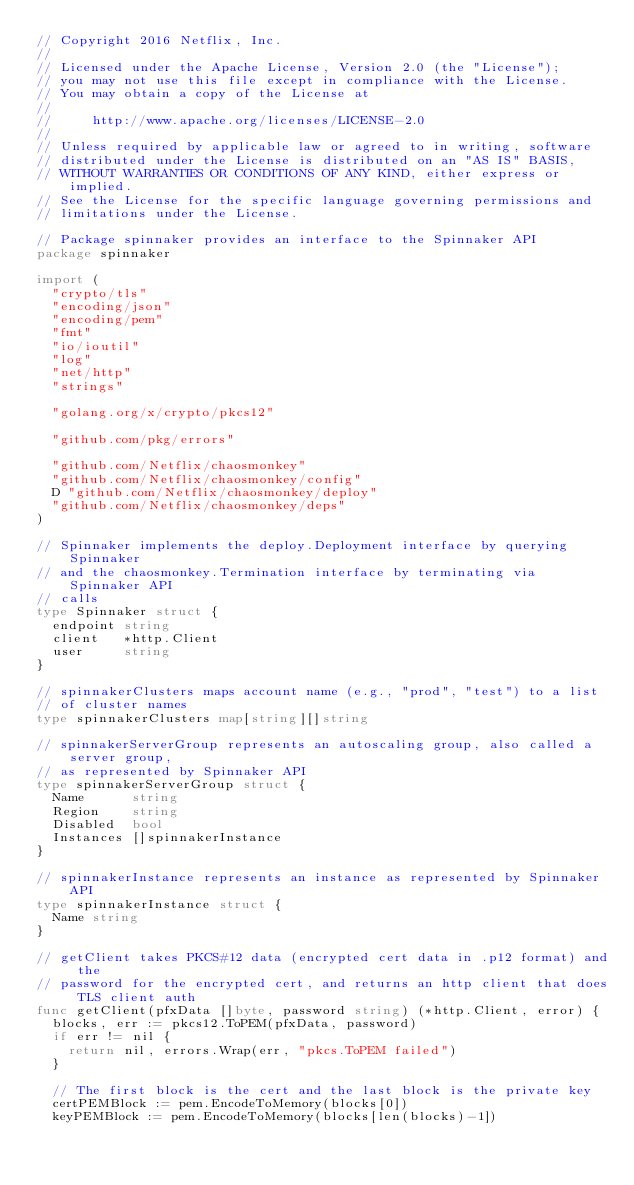Convert code to text. <code><loc_0><loc_0><loc_500><loc_500><_Go_>// Copyright 2016 Netflix, Inc.
//
// Licensed under the Apache License, Version 2.0 (the "License");
// you may not use this file except in compliance with the License.
// You may obtain a copy of the License at
//
//     http://www.apache.org/licenses/LICENSE-2.0
//
// Unless required by applicable law or agreed to in writing, software
// distributed under the License is distributed on an "AS IS" BASIS,
// WITHOUT WARRANTIES OR CONDITIONS OF ANY KIND, either express or implied.
// See the License for the specific language governing permissions and
// limitations under the License.

// Package spinnaker provides an interface to the Spinnaker API
package spinnaker

import (
	"crypto/tls"
	"encoding/json"
	"encoding/pem"
	"fmt"
	"io/ioutil"
	"log"
	"net/http"
	"strings"

	"golang.org/x/crypto/pkcs12"

	"github.com/pkg/errors"

	"github.com/Netflix/chaosmonkey"
	"github.com/Netflix/chaosmonkey/config"
	D "github.com/Netflix/chaosmonkey/deploy"
	"github.com/Netflix/chaosmonkey/deps"
)

// Spinnaker implements the deploy.Deployment interface by querying Spinnaker
// and the chaosmonkey.Termination interface by terminating via Spinnaker API
// calls
type Spinnaker struct {
	endpoint string
	client   *http.Client
	user     string
}

// spinnakerClusters maps account name (e.g., "prod", "test") to a list
// of cluster names
type spinnakerClusters map[string][]string

// spinnakerServerGroup represents an autoscaling group, also called a server group,
// as represented by Spinnaker API
type spinnakerServerGroup struct {
	Name      string
	Region    string
	Disabled  bool
	Instances []spinnakerInstance
}

// spinnakerInstance represents an instance as represented by Spinnaker API
type spinnakerInstance struct {
	Name string
}

// getClient takes PKCS#12 data (encrypted cert data in .p12 format) and the
// password for the encrypted cert, and returns an http client that does TLS client auth
func getClient(pfxData []byte, password string) (*http.Client, error) {
	blocks, err := pkcs12.ToPEM(pfxData, password)
	if err != nil {
		return nil, errors.Wrap(err, "pkcs.ToPEM failed")
	}

	// The first block is the cert and the last block is the private key
	certPEMBlock := pem.EncodeToMemory(blocks[0])
	keyPEMBlock := pem.EncodeToMemory(blocks[len(blocks)-1])
</code> 